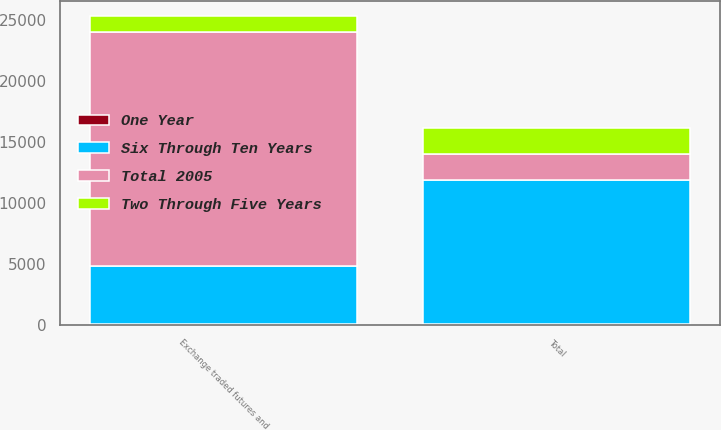<chart> <loc_0><loc_0><loc_500><loc_500><stacked_bar_chart><ecel><fcel>Exchange traded futures and<fcel>Total<nl><fcel>Total 2005<fcel>19182<fcel>2154<nl><fcel>Six Through Ten Years<fcel>4768<fcel>11785<nl><fcel>Two Through Five Years<fcel>1287<fcel>2154<nl><fcel>One Year<fcel>61<fcel>61<nl></chart> 